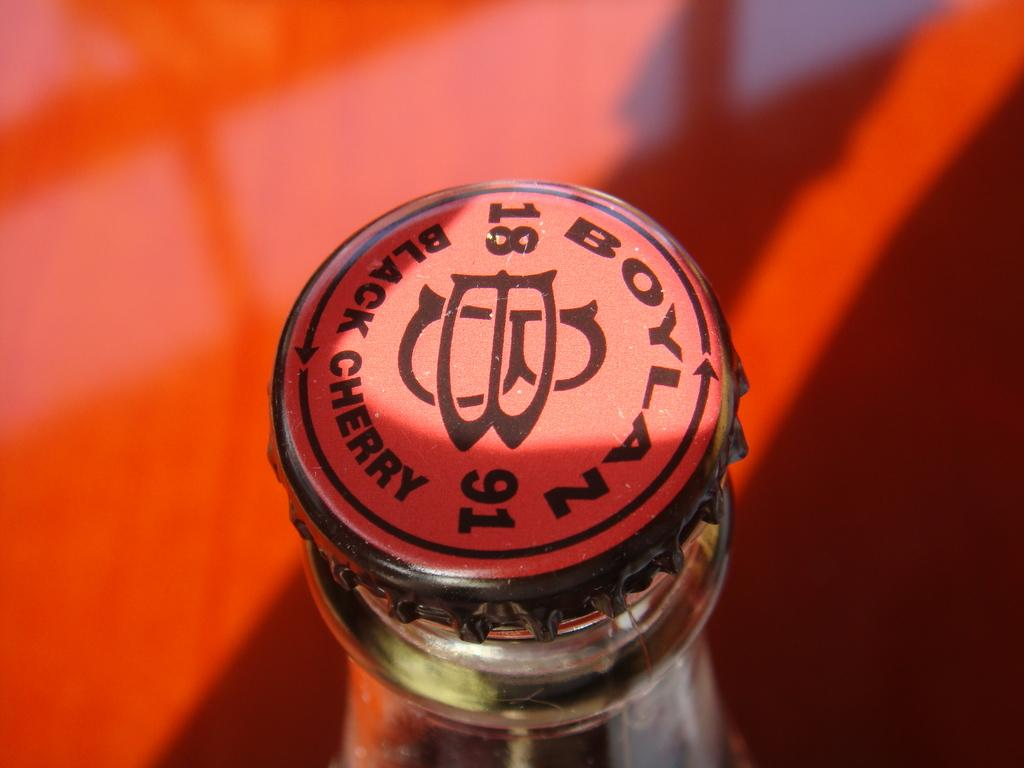<image>
Render a clear and concise summary of the photo. a top on a glass bottle with the words Black Cherry on it 